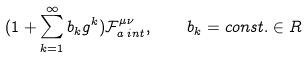<formula> <loc_0><loc_0><loc_500><loc_500>( 1 + \sum _ { k = 1 } ^ { \infty } b _ { k } g ^ { k } ) \mathcal { F } ^ { \mu \nu } _ { a \, i n t } , \quad b _ { k } = c o n s t . \in R</formula> 